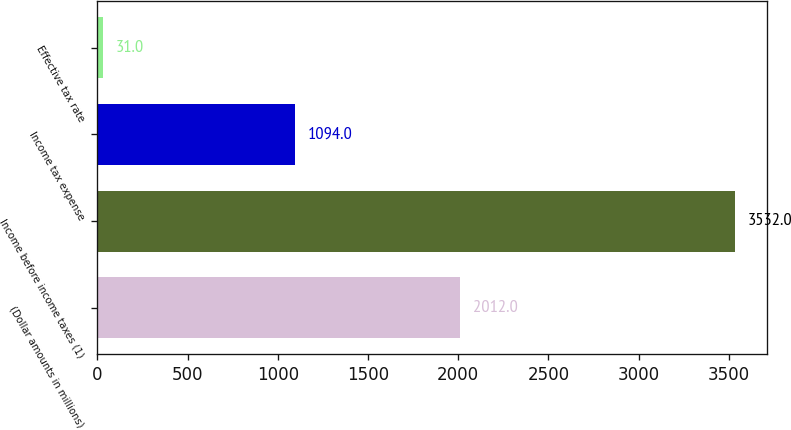Convert chart. <chart><loc_0><loc_0><loc_500><loc_500><bar_chart><fcel>(Dollar amounts in millions)<fcel>Income before income taxes (1)<fcel>Income tax expense<fcel>Effective tax rate<nl><fcel>2012<fcel>3532<fcel>1094<fcel>31<nl></chart> 